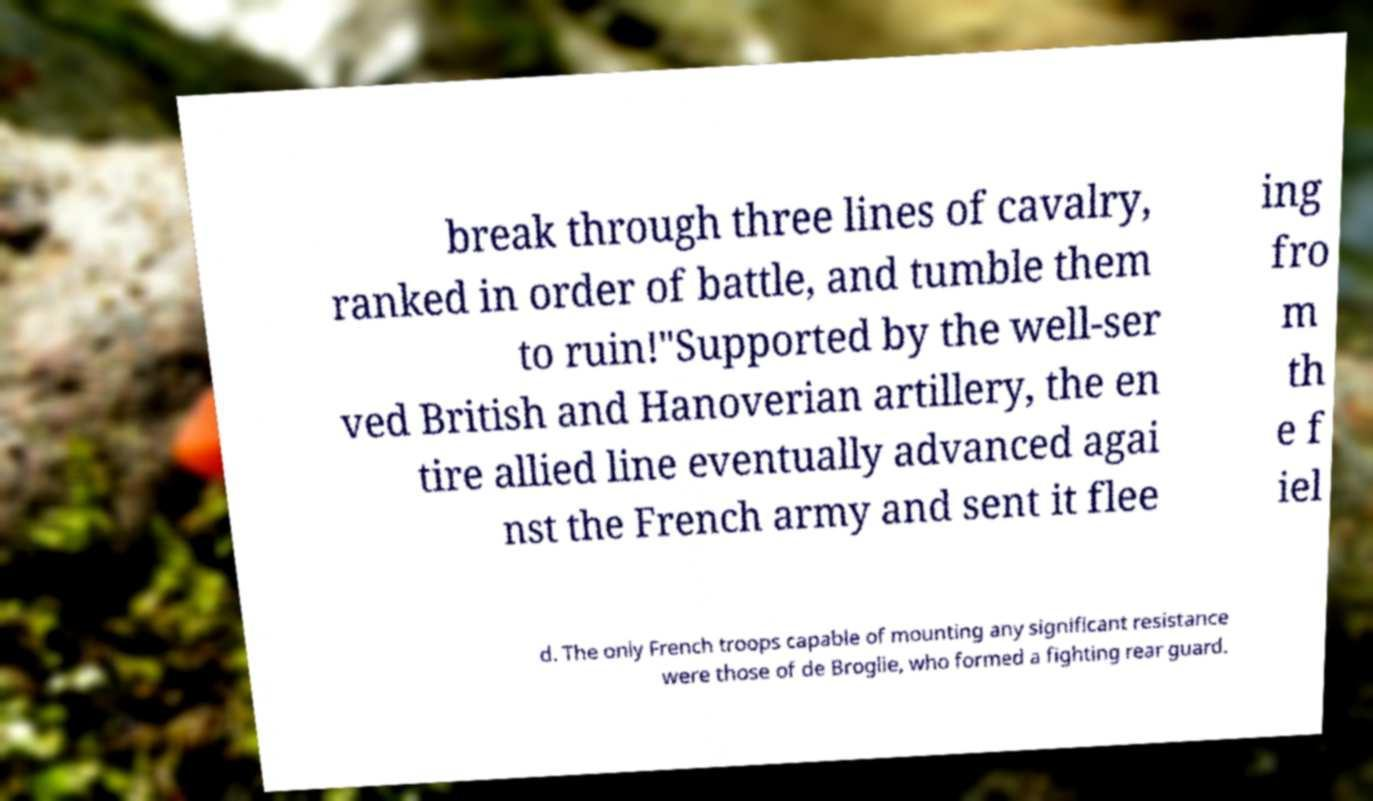Can you read and provide the text displayed in the image?This photo seems to have some interesting text. Can you extract and type it out for me? break through three lines of cavalry, ranked in order of battle, and tumble them to ruin!"Supported by the well-ser ved British and Hanoverian artillery, the en tire allied line eventually advanced agai nst the French army and sent it flee ing fro m th e f iel d. The only French troops capable of mounting any significant resistance were those of de Broglie, who formed a fighting rear guard. 